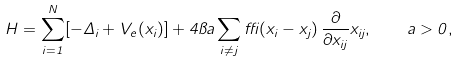<formula> <loc_0><loc_0><loc_500><loc_500>H = \sum _ { i = 1 } ^ { N } [ - \Delta _ { i } + V _ { e } ( { x } _ { i } ) ] + 4 \pi a \sum _ { i \neq j } \delta ( { x } _ { i } - { x } _ { j } ) \, \frac { \partial } { \partial x _ { i j } } x _ { i j } , \quad a > 0 ,</formula> 